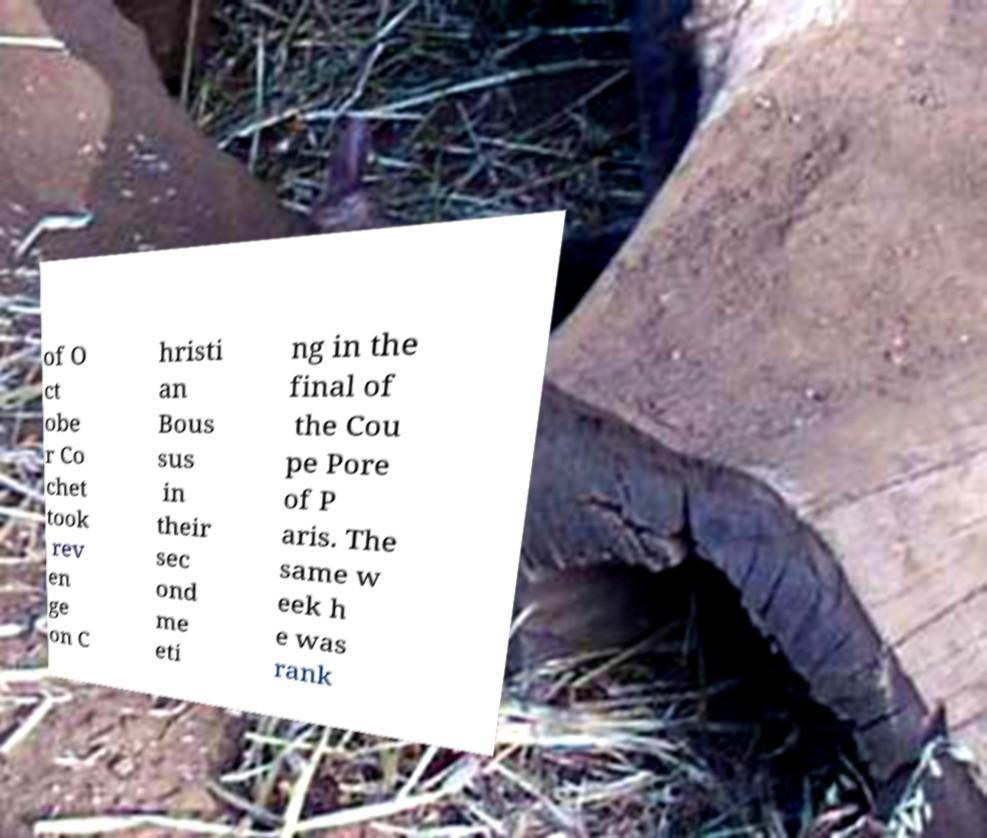What messages or text are displayed in this image? I need them in a readable, typed format. of O ct obe r Co chet took rev en ge on C hristi an Bous sus in their sec ond me eti ng in the final of the Cou pe Pore of P aris. The same w eek h e was rank 